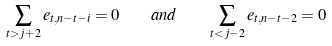<formula> <loc_0><loc_0><loc_500><loc_500>\sum _ { t > j + 2 } e _ { t , n - t - i } = 0 \quad a n d \quad \sum _ { t < j - 2 } e _ { t , n - t - 2 } = 0</formula> 